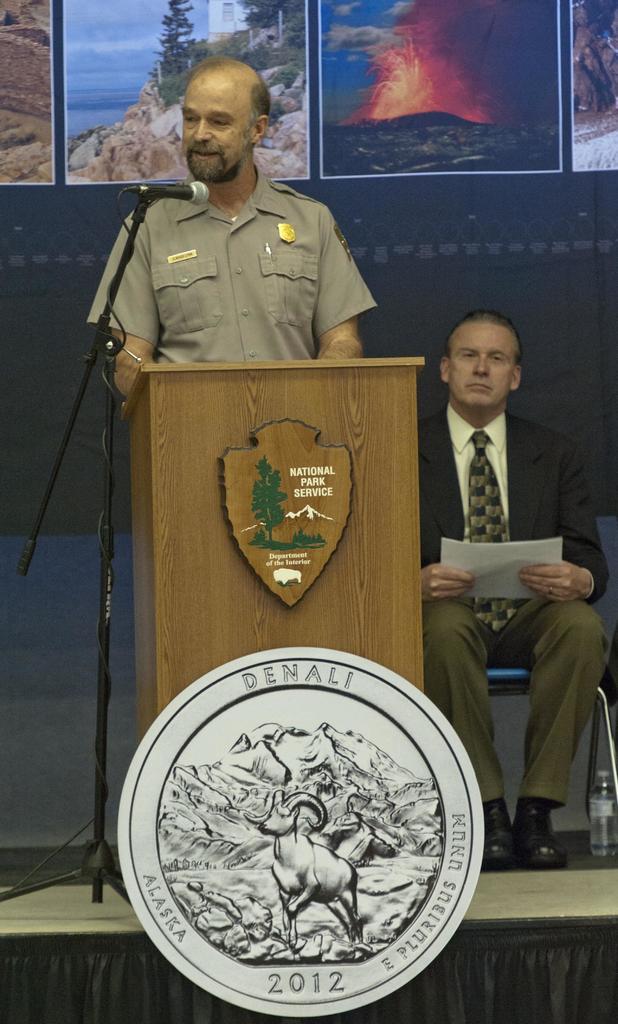What year is on the quarter?
Your answer should be very brief. 2012. What american state is written on the coin?
Provide a short and direct response. Alaska. 